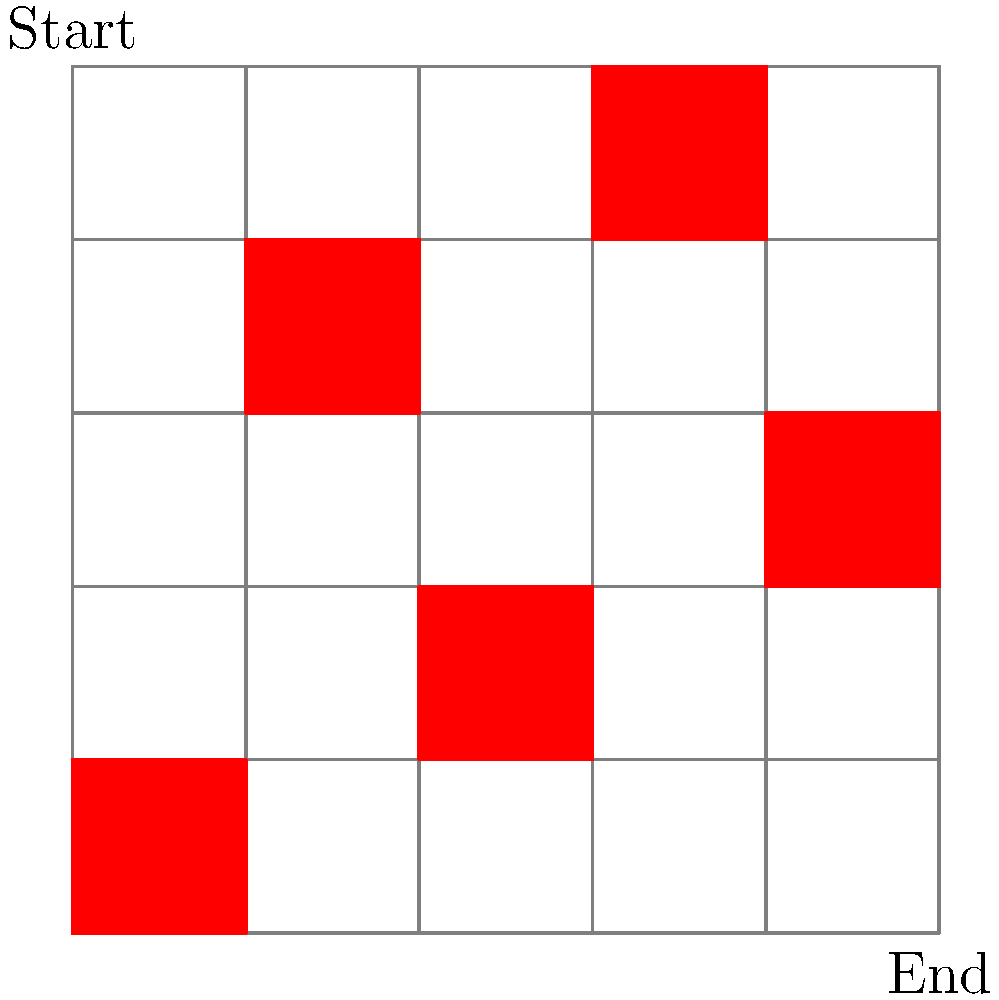You are tasked with optimizing the layout of a beach umbrella rental area. The area is represented by a 5x5 grid, where some spots are already occupied by other beach amenities (marked in red). You need to find the shortest path from the top-left corner (Start) to the bottom-right corner (End) to create an efficient walkway for customers. How many different shortest paths are there from Start to End, avoiding the occupied spots? To solve this problem, we'll use a dynamic programming approach:

1) First, we create a 6x6 grid (to include the Start and End points) and mark the occupied spots as 0 and empty spots as 1.

2) We'll use a 2D array $dp[i][j]$ to store the number of paths to reach each cell $(i,j)$.

3) Initialize the first row and column:
   - $dp[0][0] = 1$ (Start point)
   - For the first row: $dp[0][j] = dp[0][j-1]$ if cell $(0,j)$ is empty, else 0
   - For the first column: $dp[i][0] = dp[i-1][0]$ if cell $(i,0)$ is empty, else 0

4) For the rest of the cells, we use the recurrence relation:
   $dp[i][j] = dp[i-1][j] + dp[i][j-1]$ if cell $(i,j)$ is empty, else 0

5) The value in $dp[5][5]$ will give us the total number of shortest paths.

Let's fill the dp array:

$$
\begin{array}{c|cccccc}
  & 0 & 1 & 2 & 3 & 4 & 5 \\
\hline
0 & 1 & 0 & 1 & 1 & 1 & 1 \\
1 & 1 & 0 & 1 & 0 & 1 & 1 \\
2 & 1 & 1 & 1 & 0 & 1 & 0 \\
3 & 1 & 0 & 1 & 1 & 1 & 1 \\
4 & 1 & 1 & 1 & 1 & 0 & 1 \\
5 & 1 & 2 & 3 & 4 & 4 & 5 \\
\end{array}
$$

Therefore, there are 5 different shortest paths from Start to End.
Answer: 5 paths 